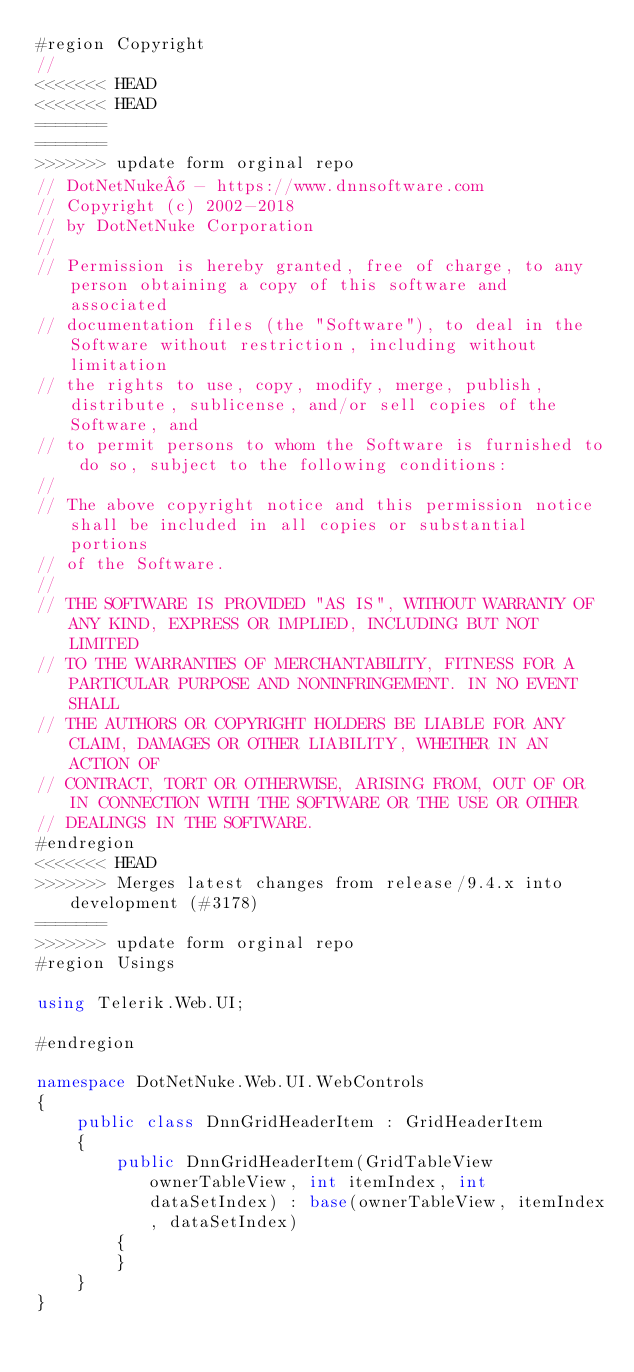Convert code to text. <code><loc_0><loc_0><loc_500><loc_500><_C#_>#region Copyright
// 
<<<<<<< HEAD
<<<<<<< HEAD
=======
=======
>>>>>>> update form orginal repo
// DotNetNuke® - https://www.dnnsoftware.com
// Copyright (c) 2002-2018
// by DotNetNuke Corporation
// 
// Permission is hereby granted, free of charge, to any person obtaining a copy of this software and associated 
// documentation files (the "Software"), to deal in the Software without restriction, including without limitation 
// the rights to use, copy, modify, merge, publish, distribute, sublicense, and/or sell copies of the Software, and 
// to permit persons to whom the Software is furnished to do so, subject to the following conditions:
// 
// The above copyright notice and this permission notice shall be included in all copies or substantial portions 
// of the Software.
// 
// THE SOFTWARE IS PROVIDED "AS IS", WITHOUT WARRANTY OF ANY KIND, EXPRESS OR IMPLIED, INCLUDING BUT NOT LIMITED 
// TO THE WARRANTIES OF MERCHANTABILITY, FITNESS FOR A PARTICULAR PURPOSE AND NONINFRINGEMENT. IN NO EVENT SHALL 
// THE AUTHORS OR COPYRIGHT HOLDERS BE LIABLE FOR ANY CLAIM, DAMAGES OR OTHER LIABILITY, WHETHER IN AN ACTION OF 
// CONTRACT, TORT OR OTHERWISE, ARISING FROM, OUT OF OR IN CONNECTION WITH THE SOFTWARE OR THE USE OR OTHER 
// DEALINGS IN THE SOFTWARE.
#endregion
<<<<<<< HEAD
>>>>>>> Merges latest changes from release/9.4.x into development (#3178)
=======
>>>>>>> update form orginal repo
#region Usings

using Telerik.Web.UI;

#endregion

namespace DotNetNuke.Web.UI.WebControls
{
    public class DnnGridHeaderItem : GridHeaderItem
    {
        public DnnGridHeaderItem(GridTableView ownerTableView, int itemIndex, int dataSetIndex) : base(ownerTableView, itemIndex, dataSetIndex)
        {
        }
    }
}</code> 